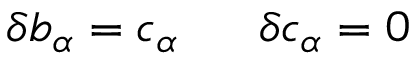Convert formula to latex. <formula><loc_0><loc_0><loc_500><loc_500>\delta b _ { \alpha } = c _ { \alpha } \, \delta c _ { \alpha } = 0</formula> 